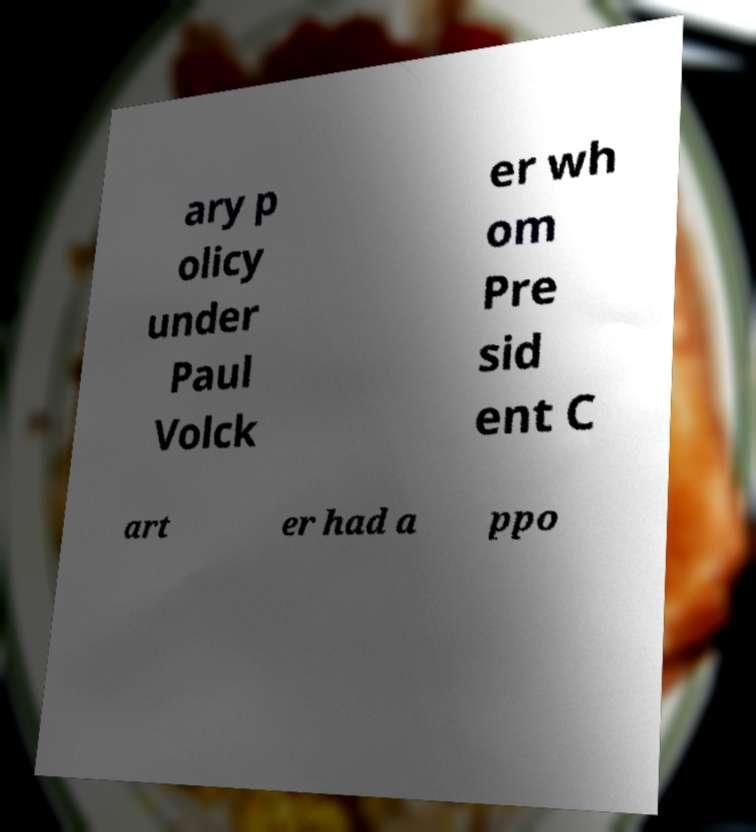For documentation purposes, I need the text within this image transcribed. Could you provide that? ary p olicy under Paul Volck er wh om Pre sid ent C art er had a ppo 